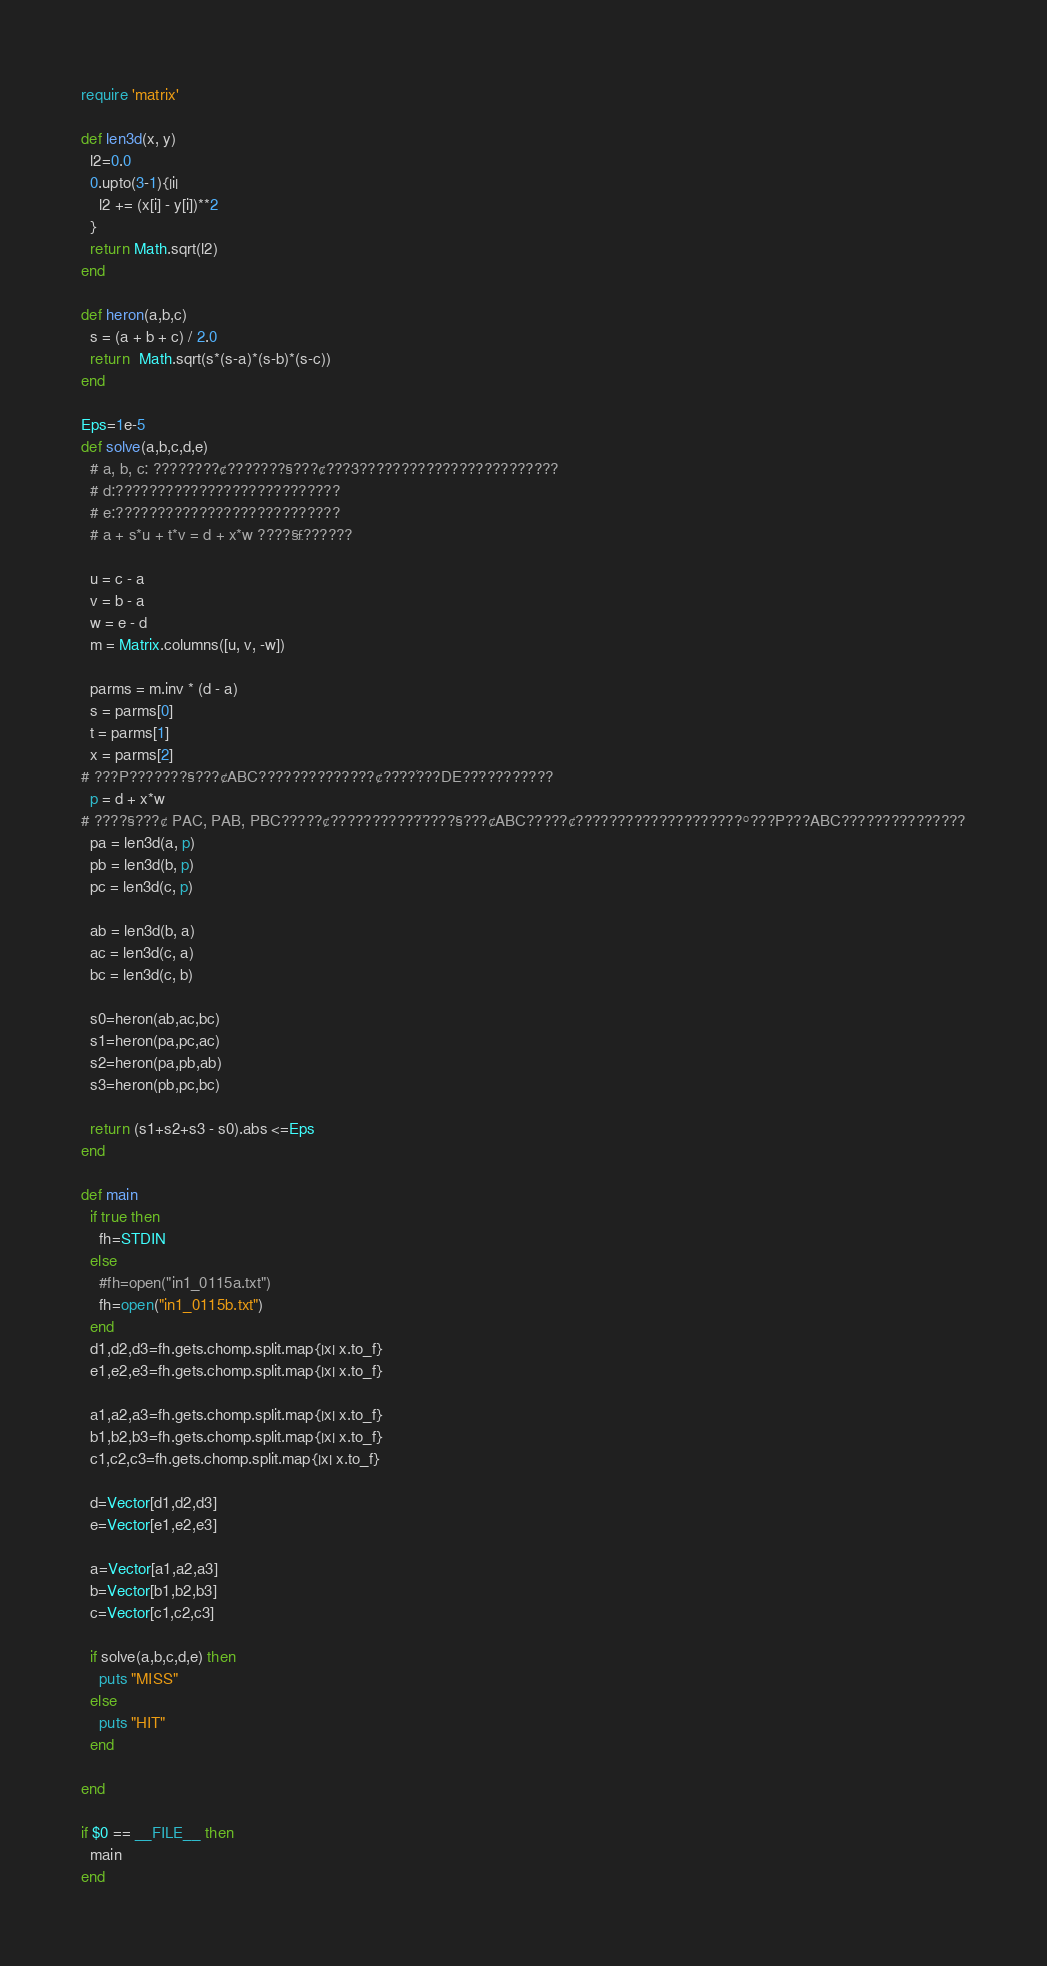Convert code to text. <code><loc_0><loc_0><loc_500><loc_500><_Ruby_>require 'matrix'

def len3d(x, y)
  l2=0.0
  0.upto(3-1){|i|
    l2 += (x[i] - y[i])**2
  }
  return Math.sqrt(l2)
end

def heron(a,b,c)
  s = (a + b + c) / 2.0
  return  Math.sqrt(s*(s-a)*(s-b)*(s-c))
end

Eps=1e-5
def solve(a,b,c,d,e)
  # a, b, c: ????????¢???????§???¢???3????????????????????????
  # d:???????????????????????????
  # e:???????????????????????????
  # a + s*u + t*v = d + x*w ????§£??????

  u = c - a
  v = b - a
  w = e - d
  m = Matrix.columns([u, v, -w])

  parms = m.inv * (d - a)
  s = parms[0]
  t = parms[1]
  x = parms[2]
# ???P???????§???¢ABC??????????????¢??¨??´???DE??¨?????????
  p = d + x*w
# ????§???¢ PAC, PAB, PBC?????¢???????????¨????§???¢ABC?????¢????????????????????°???P???ABC???????????????
  pa = len3d(a, p)
  pb = len3d(b, p)
  pc = len3d(c, p)

  ab = len3d(b, a)
  ac = len3d(c, a)
  bc = len3d(c, b)

  s0=heron(ab,ac,bc)
  s1=heron(pa,pc,ac)
  s2=heron(pa,pb,ab)
  s3=heron(pb,pc,bc)

  return (s1+s2+s3 - s0).abs <=Eps
end

def main
  if true then
    fh=STDIN
  else
    #fh=open("in1_0115a.txt")
    fh=open("in1_0115b.txt")
  end
  d1,d2,d3=fh.gets.chomp.split.map{|x| x.to_f}
  e1,e2,e3=fh.gets.chomp.split.map{|x| x.to_f}

  a1,a2,a3=fh.gets.chomp.split.map{|x| x.to_f}
  b1,b2,b3=fh.gets.chomp.split.map{|x| x.to_f}
  c1,c2,c3=fh.gets.chomp.split.map{|x| x.to_f}

  d=Vector[d1,d2,d3]
  e=Vector[e1,e2,e3]

  a=Vector[a1,a2,a3]
  b=Vector[b1,b2,b3]
  c=Vector[c1,c2,c3]

  if solve(a,b,c,d,e) then
    puts "MISS"
  else
    puts "HIT"
  end

end

if $0 == __FILE__ then
  main
end</code> 